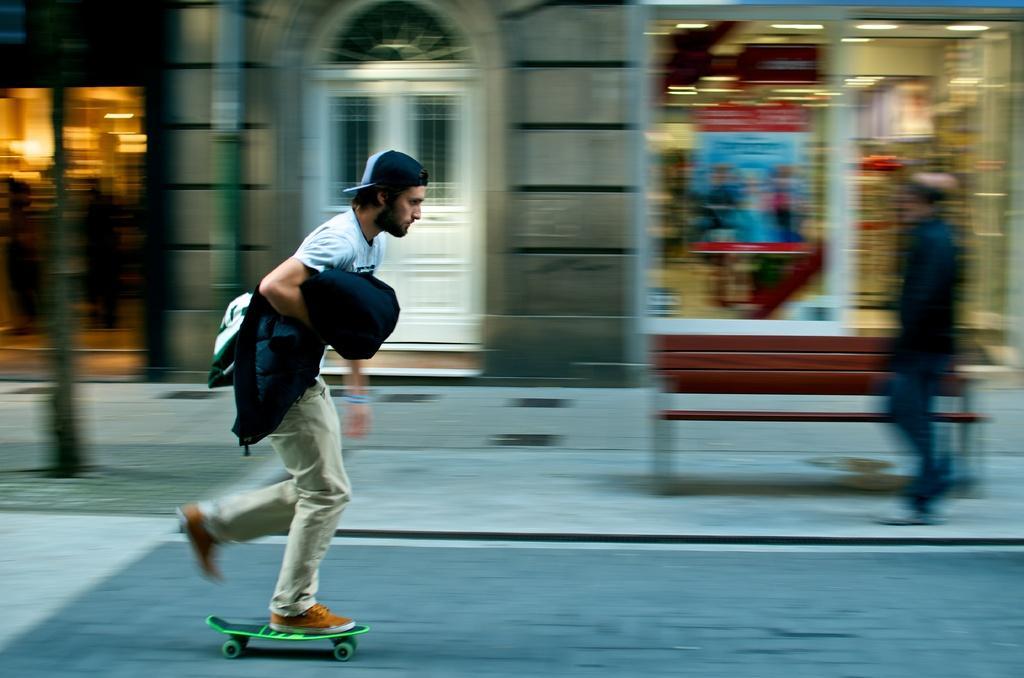Please provide a concise description of this image. There is one man skating on the road as we can see on the left side of this image. There is one more person is on the right side of this image and there is a wall and a door in the background. 